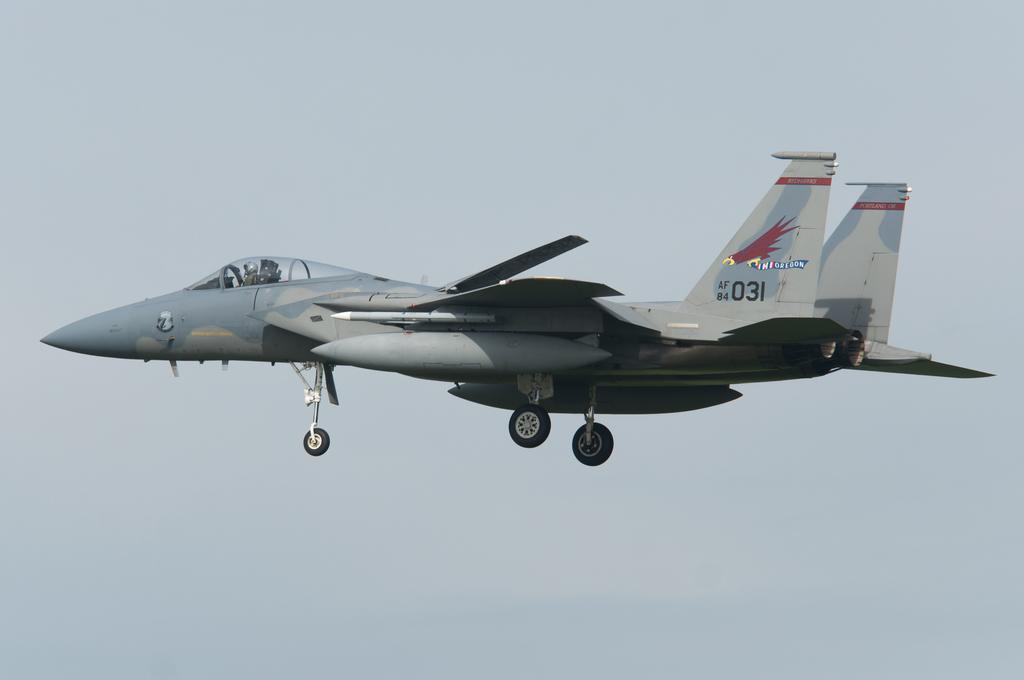Provide a one-sentence caption for the provided image. fighter jet with eagle carrying oregon banner on tail and id AF 84 031. 